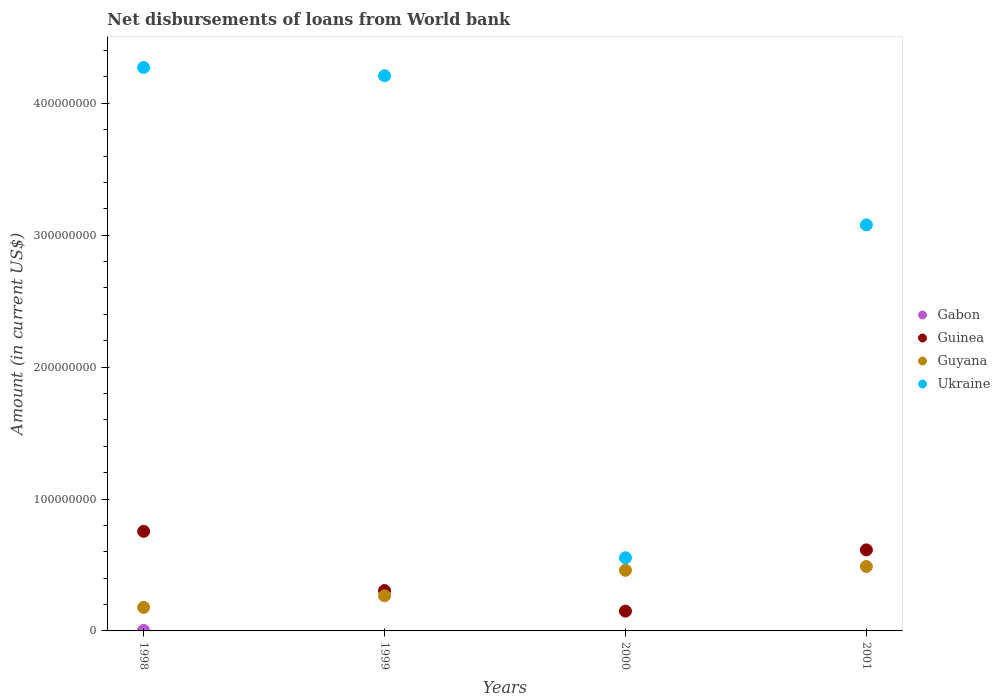How many different coloured dotlines are there?
Offer a terse response. 4. Across all years, what is the maximum amount of loan disbursed from World Bank in Gabon?
Your response must be concise. 4.01e+05. Across all years, what is the minimum amount of loan disbursed from World Bank in Ukraine?
Offer a very short reply. 5.55e+07. What is the total amount of loan disbursed from World Bank in Guyana in the graph?
Make the answer very short. 1.39e+08. What is the difference between the amount of loan disbursed from World Bank in Guyana in 1998 and that in 2001?
Offer a very short reply. -3.10e+07. What is the difference between the amount of loan disbursed from World Bank in Guyana in 1998 and the amount of loan disbursed from World Bank in Gabon in 2000?
Your response must be concise. 1.79e+07. What is the average amount of loan disbursed from World Bank in Gabon per year?
Your response must be concise. 1.00e+05. In the year 2001, what is the difference between the amount of loan disbursed from World Bank in Guyana and amount of loan disbursed from World Bank in Ukraine?
Keep it short and to the point. -2.59e+08. In how many years, is the amount of loan disbursed from World Bank in Guinea greater than 420000000 US$?
Keep it short and to the point. 0. What is the ratio of the amount of loan disbursed from World Bank in Guinea in 1999 to that in 2000?
Your response must be concise. 2.04. What is the difference between the highest and the second highest amount of loan disbursed from World Bank in Guinea?
Your response must be concise. 1.41e+07. What is the difference between the highest and the lowest amount of loan disbursed from World Bank in Ukraine?
Offer a terse response. 3.72e+08. Is the sum of the amount of loan disbursed from World Bank in Guinea in 1998 and 1999 greater than the maximum amount of loan disbursed from World Bank in Guyana across all years?
Your response must be concise. Yes. Does the amount of loan disbursed from World Bank in Ukraine monotonically increase over the years?
Your answer should be compact. No. Is the amount of loan disbursed from World Bank in Guinea strictly greater than the amount of loan disbursed from World Bank in Guyana over the years?
Your answer should be compact. No. How many years are there in the graph?
Your answer should be compact. 4. Are the values on the major ticks of Y-axis written in scientific E-notation?
Keep it short and to the point. No. Does the graph contain any zero values?
Provide a succinct answer. Yes. Where does the legend appear in the graph?
Provide a short and direct response. Center right. What is the title of the graph?
Your response must be concise. Net disbursements of loans from World bank. Does "Italy" appear as one of the legend labels in the graph?
Your answer should be compact. No. What is the Amount (in current US$) in Gabon in 1998?
Provide a short and direct response. 4.01e+05. What is the Amount (in current US$) of Guinea in 1998?
Make the answer very short. 7.55e+07. What is the Amount (in current US$) of Guyana in 1998?
Provide a succinct answer. 1.79e+07. What is the Amount (in current US$) in Ukraine in 1998?
Offer a very short reply. 4.27e+08. What is the Amount (in current US$) of Gabon in 1999?
Give a very brief answer. 0. What is the Amount (in current US$) of Guinea in 1999?
Make the answer very short. 3.06e+07. What is the Amount (in current US$) of Guyana in 1999?
Your response must be concise. 2.66e+07. What is the Amount (in current US$) in Ukraine in 1999?
Offer a terse response. 4.21e+08. What is the Amount (in current US$) of Guinea in 2000?
Keep it short and to the point. 1.50e+07. What is the Amount (in current US$) in Guyana in 2000?
Provide a short and direct response. 4.60e+07. What is the Amount (in current US$) in Ukraine in 2000?
Provide a succinct answer. 5.55e+07. What is the Amount (in current US$) of Gabon in 2001?
Provide a short and direct response. 0. What is the Amount (in current US$) of Guinea in 2001?
Ensure brevity in your answer.  6.14e+07. What is the Amount (in current US$) in Guyana in 2001?
Your answer should be compact. 4.88e+07. What is the Amount (in current US$) of Ukraine in 2001?
Your answer should be very brief. 3.08e+08. Across all years, what is the maximum Amount (in current US$) in Gabon?
Offer a terse response. 4.01e+05. Across all years, what is the maximum Amount (in current US$) of Guinea?
Offer a very short reply. 7.55e+07. Across all years, what is the maximum Amount (in current US$) in Guyana?
Provide a succinct answer. 4.88e+07. Across all years, what is the maximum Amount (in current US$) in Ukraine?
Your response must be concise. 4.27e+08. Across all years, what is the minimum Amount (in current US$) in Guinea?
Make the answer very short. 1.50e+07. Across all years, what is the minimum Amount (in current US$) of Guyana?
Ensure brevity in your answer.  1.79e+07. Across all years, what is the minimum Amount (in current US$) in Ukraine?
Your response must be concise. 5.55e+07. What is the total Amount (in current US$) in Gabon in the graph?
Your response must be concise. 4.01e+05. What is the total Amount (in current US$) in Guinea in the graph?
Provide a succinct answer. 1.83e+08. What is the total Amount (in current US$) of Guyana in the graph?
Keep it short and to the point. 1.39e+08. What is the total Amount (in current US$) of Ukraine in the graph?
Your answer should be very brief. 1.21e+09. What is the difference between the Amount (in current US$) in Guinea in 1998 and that in 1999?
Offer a terse response. 4.49e+07. What is the difference between the Amount (in current US$) in Guyana in 1998 and that in 1999?
Offer a very short reply. -8.77e+06. What is the difference between the Amount (in current US$) of Ukraine in 1998 and that in 1999?
Give a very brief answer. 6.27e+06. What is the difference between the Amount (in current US$) of Guinea in 1998 and that in 2000?
Provide a succinct answer. 6.05e+07. What is the difference between the Amount (in current US$) in Guyana in 1998 and that in 2000?
Your response must be concise. -2.81e+07. What is the difference between the Amount (in current US$) of Ukraine in 1998 and that in 2000?
Offer a terse response. 3.72e+08. What is the difference between the Amount (in current US$) in Guinea in 1998 and that in 2001?
Your answer should be compact. 1.41e+07. What is the difference between the Amount (in current US$) of Guyana in 1998 and that in 2001?
Your answer should be compact. -3.10e+07. What is the difference between the Amount (in current US$) of Ukraine in 1998 and that in 2001?
Provide a succinct answer. 1.19e+08. What is the difference between the Amount (in current US$) of Guinea in 1999 and that in 2000?
Offer a very short reply. 1.56e+07. What is the difference between the Amount (in current US$) in Guyana in 1999 and that in 2000?
Your answer should be very brief. -1.93e+07. What is the difference between the Amount (in current US$) of Ukraine in 1999 and that in 2000?
Keep it short and to the point. 3.65e+08. What is the difference between the Amount (in current US$) of Guinea in 1999 and that in 2001?
Your answer should be very brief. -3.08e+07. What is the difference between the Amount (in current US$) in Guyana in 1999 and that in 2001?
Your response must be concise. -2.22e+07. What is the difference between the Amount (in current US$) of Ukraine in 1999 and that in 2001?
Offer a very short reply. 1.13e+08. What is the difference between the Amount (in current US$) of Guinea in 2000 and that in 2001?
Ensure brevity in your answer.  -4.64e+07. What is the difference between the Amount (in current US$) in Guyana in 2000 and that in 2001?
Give a very brief answer. -2.88e+06. What is the difference between the Amount (in current US$) in Ukraine in 2000 and that in 2001?
Your response must be concise. -2.52e+08. What is the difference between the Amount (in current US$) of Gabon in 1998 and the Amount (in current US$) of Guinea in 1999?
Your answer should be very brief. -3.02e+07. What is the difference between the Amount (in current US$) of Gabon in 1998 and the Amount (in current US$) of Guyana in 1999?
Offer a very short reply. -2.62e+07. What is the difference between the Amount (in current US$) in Gabon in 1998 and the Amount (in current US$) in Ukraine in 1999?
Provide a short and direct response. -4.21e+08. What is the difference between the Amount (in current US$) of Guinea in 1998 and the Amount (in current US$) of Guyana in 1999?
Make the answer very short. 4.89e+07. What is the difference between the Amount (in current US$) of Guinea in 1998 and the Amount (in current US$) of Ukraine in 1999?
Make the answer very short. -3.45e+08. What is the difference between the Amount (in current US$) of Guyana in 1998 and the Amount (in current US$) of Ukraine in 1999?
Offer a very short reply. -4.03e+08. What is the difference between the Amount (in current US$) of Gabon in 1998 and the Amount (in current US$) of Guinea in 2000?
Your answer should be very brief. -1.46e+07. What is the difference between the Amount (in current US$) in Gabon in 1998 and the Amount (in current US$) in Guyana in 2000?
Keep it short and to the point. -4.56e+07. What is the difference between the Amount (in current US$) in Gabon in 1998 and the Amount (in current US$) in Ukraine in 2000?
Offer a very short reply. -5.51e+07. What is the difference between the Amount (in current US$) in Guinea in 1998 and the Amount (in current US$) in Guyana in 2000?
Keep it short and to the point. 2.96e+07. What is the difference between the Amount (in current US$) of Guinea in 1998 and the Amount (in current US$) of Ukraine in 2000?
Offer a terse response. 2.01e+07. What is the difference between the Amount (in current US$) in Guyana in 1998 and the Amount (in current US$) in Ukraine in 2000?
Your answer should be compact. -3.76e+07. What is the difference between the Amount (in current US$) of Gabon in 1998 and the Amount (in current US$) of Guinea in 2001?
Give a very brief answer. -6.10e+07. What is the difference between the Amount (in current US$) in Gabon in 1998 and the Amount (in current US$) in Guyana in 2001?
Keep it short and to the point. -4.84e+07. What is the difference between the Amount (in current US$) in Gabon in 1998 and the Amount (in current US$) in Ukraine in 2001?
Your answer should be compact. -3.07e+08. What is the difference between the Amount (in current US$) of Guinea in 1998 and the Amount (in current US$) of Guyana in 2001?
Provide a succinct answer. 2.67e+07. What is the difference between the Amount (in current US$) in Guinea in 1998 and the Amount (in current US$) in Ukraine in 2001?
Make the answer very short. -2.32e+08. What is the difference between the Amount (in current US$) in Guyana in 1998 and the Amount (in current US$) in Ukraine in 2001?
Provide a short and direct response. -2.90e+08. What is the difference between the Amount (in current US$) in Guinea in 1999 and the Amount (in current US$) in Guyana in 2000?
Keep it short and to the point. -1.53e+07. What is the difference between the Amount (in current US$) of Guinea in 1999 and the Amount (in current US$) of Ukraine in 2000?
Offer a terse response. -2.49e+07. What is the difference between the Amount (in current US$) in Guyana in 1999 and the Amount (in current US$) in Ukraine in 2000?
Give a very brief answer. -2.88e+07. What is the difference between the Amount (in current US$) in Guinea in 1999 and the Amount (in current US$) in Guyana in 2001?
Your answer should be very brief. -1.82e+07. What is the difference between the Amount (in current US$) in Guinea in 1999 and the Amount (in current US$) in Ukraine in 2001?
Make the answer very short. -2.77e+08. What is the difference between the Amount (in current US$) in Guyana in 1999 and the Amount (in current US$) in Ukraine in 2001?
Your answer should be very brief. -2.81e+08. What is the difference between the Amount (in current US$) of Guinea in 2000 and the Amount (in current US$) of Guyana in 2001?
Keep it short and to the point. -3.38e+07. What is the difference between the Amount (in current US$) of Guinea in 2000 and the Amount (in current US$) of Ukraine in 2001?
Offer a very short reply. -2.93e+08. What is the difference between the Amount (in current US$) of Guyana in 2000 and the Amount (in current US$) of Ukraine in 2001?
Ensure brevity in your answer.  -2.62e+08. What is the average Amount (in current US$) in Gabon per year?
Your answer should be compact. 1.00e+05. What is the average Amount (in current US$) in Guinea per year?
Your answer should be compact. 4.56e+07. What is the average Amount (in current US$) in Guyana per year?
Offer a terse response. 3.48e+07. What is the average Amount (in current US$) of Ukraine per year?
Give a very brief answer. 3.03e+08. In the year 1998, what is the difference between the Amount (in current US$) of Gabon and Amount (in current US$) of Guinea?
Ensure brevity in your answer.  -7.51e+07. In the year 1998, what is the difference between the Amount (in current US$) of Gabon and Amount (in current US$) of Guyana?
Ensure brevity in your answer.  -1.75e+07. In the year 1998, what is the difference between the Amount (in current US$) in Gabon and Amount (in current US$) in Ukraine?
Provide a succinct answer. -4.27e+08. In the year 1998, what is the difference between the Amount (in current US$) in Guinea and Amount (in current US$) in Guyana?
Provide a short and direct response. 5.77e+07. In the year 1998, what is the difference between the Amount (in current US$) in Guinea and Amount (in current US$) in Ukraine?
Give a very brief answer. -3.52e+08. In the year 1998, what is the difference between the Amount (in current US$) in Guyana and Amount (in current US$) in Ukraine?
Offer a terse response. -4.09e+08. In the year 1999, what is the difference between the Amount (in current US$) in Guinea and Amount (in current US$) in Guyana?
Ensure brevity in your answer.  3.98e+06. In the year 1999, what is the difference between the Amount (in current US$) of Guinea and Amount (in current US$) of Ukraine?
Provide a succinct answer. -3.90e+08. In the year 1999, what is the difference between the Amount (in current US$) of Guyana and Amount (in current US$) of Ukraine?
Offer a terse response. -3.94e+08. In the year 2000, what is the difference between the Amount (in current US$) of Guinea and Amount (in current US$) of Guyana?
Provide a succinct answer. -3.09e+07. In the year 2000, what is the difference between the Amount (in current US$) of Guinea and Amount (in current US$) of Ukraine?
Give a very brief answer. -4.05e+07. In the year 2000, what is the difference between the Amount (in current US$) in Guyana and Amount (in current US$) in Ukraine?
Keep it short and to the point. -9.51e+06. In the year 2001, what is the difference between the Amount (in current US$) of Guinea and Amount (in current US$) of Guyana?
Make the answer very short. 1.26e+07. In the year 2001, what is the difference between the Amount (in current US$) in Guinea and Amount (in current US$) in Ukraine?
Your answer should be compact. -2.46e+08. In the year 2001, what is the difference between the Amount (in current US$) in Guyana and Amount (in current US$) in Ukraine?
Offer a terse response. -2.59e+08. What is the ratio of the Amount (in current US$) in Guinea in 1998 to that in 1999?
Keep it short and to the point. 2.47. What is the ratio of the Amount (in current US$) of Guyana in 1998 to that in 1999?
Keep it short and to the point. 0.67. What is the ratio of the Amount (in current US$) of Ukraine in 1998 to that in 1999?
Give a very brief answer. 1.01. What is the ratio of the Amount (in current US$) in Guinea in 1998 to that in 2000?
Your answer should be very brief. 5.03. What is the ratio of the Amount (in current US$) in Guyana in 1998 to that in 2000?
Your response must be concise. 0.39. What is the ratio of the Amount (in current US$) of Ukraine in 1998 to that in 2000?
Your answer should be very brief. 7.7. What is the ratio of the Amount (in current US$) in Guinea in 1998 to that in 2001?
Provide a short and direct response. 1.23. What is the ratio of the Amount (in current US$) in Guyana in 1998 to that in 2001?
Provide a succinct answer. 0.37. What is the ratio of the Amount (in current US$) in Ukraine in 1998 to that in 2001?
Your answer should be very brief. 1.39. What is the ratio of the Amount (in current US$) in Guinea in 1999 to that in 2000?
Provide a succinct answer. 2.04. What is the ratio of the Amount (in current US$) in Guyana in 1999 to that in 2000?
Your answer should be compact. 0.58. What is the ratio of the Amount (in current US$) of Ukraine in 1999 to that in 2000?
Your response must be concise. 7.59. What is the ratio of the Amount (in current US$) of Guinea in 1999 to that in 2001?
Your answer should be compact. 0.5. What is the ratio of the Amount (in current US$) of Guyana in 1999 to that in 2001?
Offer a very short reply. 0.55. What is the ratio of the Amount (in current US$) in Ukraine in 1999 to that in 2001?
Make the answer very short. 1.37. What is the ratio of the Amount (in current US$) in Guinea in 2000 to that in 2001?
Offer a very short reply. 0.24. What is the ratio of the Amount (in current US$) in Guyana in 2000 to that in 2001?
Your answer should be compact. 0.94. What is the ratio of the Amount (in current US$) of Ukraine in 2000 to that in 2001?
Your answer should be very brief. 0.18. What is the difference between the highest and the second highest Amount (in current US$) in Guinea?
Offer a very short reply. 1.41e+07. What is the difference between the highest and the second highest Amount (in current US$) in Guyana?
Your answer should be compact. 2.88e+06. What is the difference between the highest and the second highest Amount (in current US$) of Ukraine?
Make the answer very short. 6.27e+06. What is the difference between the highest and the lowest Amount (in current US$) of Gabon?
Offer a very short reply. 4.01e+05. What is the difference between the highest and the lowest Amount (in current US$) of Guinea?
Provide a succinct answer. 6.05e+07. What is the difference between the highest and the lowest Amount (in current US$) in Guyana?
Your response must be concise. 3.10e+07. What is the difference between the highest and the lowest Amount (in current US$) of Ukraine?
Offer a very short reply. 3.72e+08. 